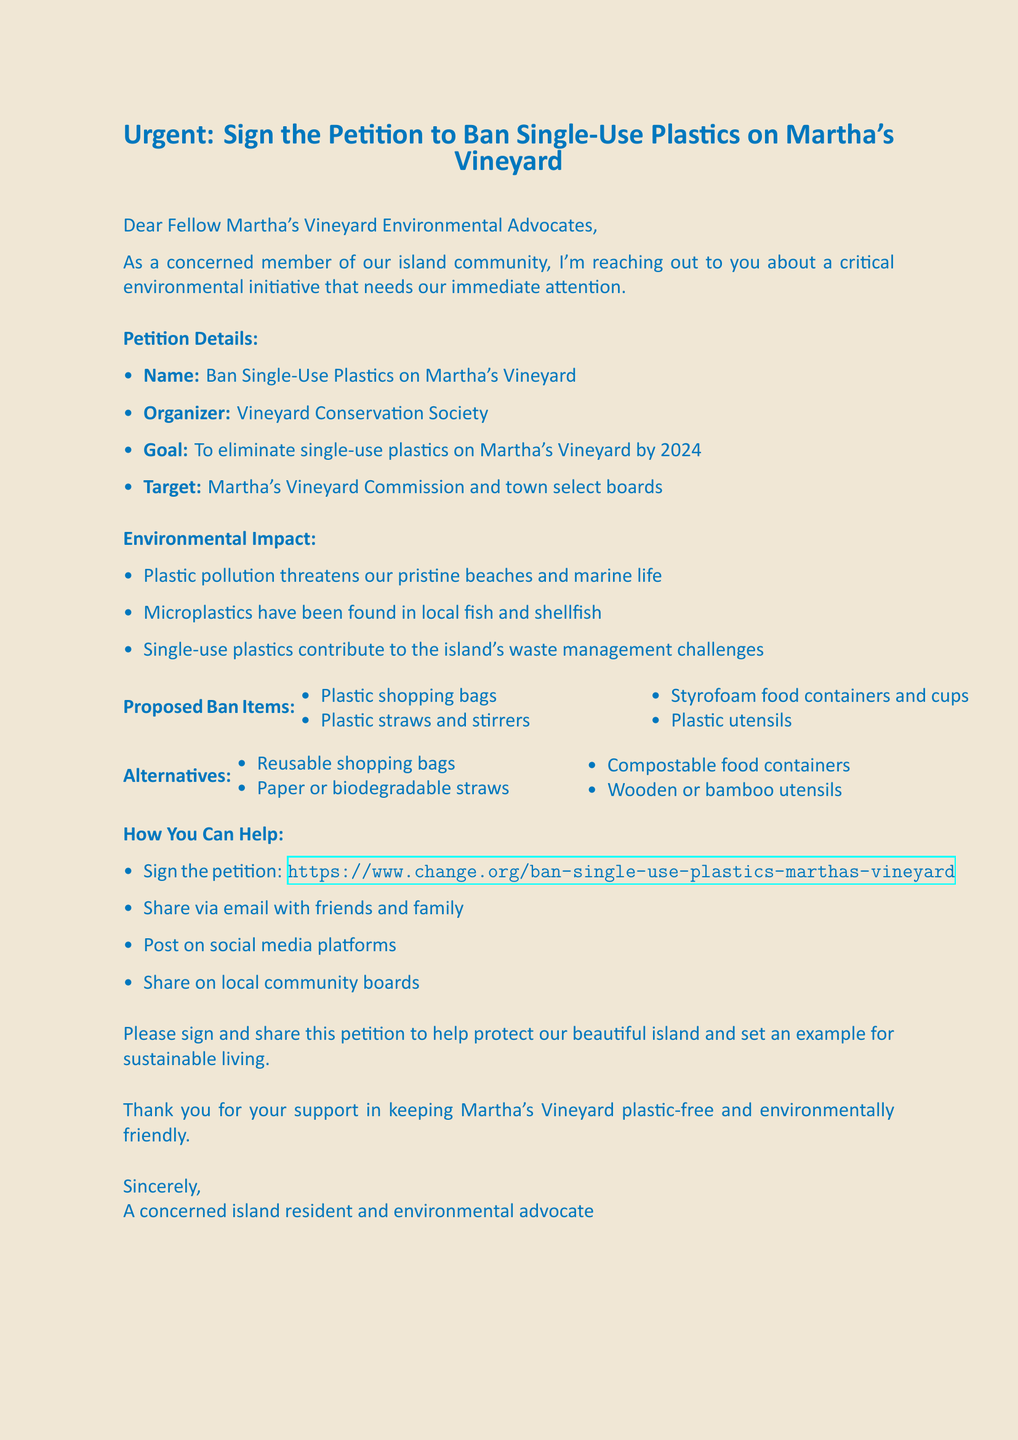What is the main goal of the petition? The main goal of the petition is to eliminate single-use plastics on Martha's Vineyard by 2024.
Answer: To eliminate single-use plastics on Martha's Vineyard by 2024 Who is organizing the petition? The petition is organized by the Vineyard Conservation Society.
Answer: Vineyard Conservation Society What items are proposed to be banned? The proposed ban items include various plastic products listed in the document.
Answer: Plastic shopping bags, plastic straws and stirrers, Styrofoam food containers and cups, plastic utensils What is one alternative to single-use plastics mentioned? The document mentions alternatives to single-use plastics, one of which is reusable shopping bags.
Answer: Reusable shopping bags What environmental issue is specifically mentioned regarding marine life? The document states that microplastics have been found in local fish and shellfish.
Answer: Microplastics have been found in local fish and shellfish How can supporters share the petition? Supporters can share the petition through various methods listed in the document.
Answer: Email, social media platforms, local community boards What is the call to action in the email? The call to action encourages recipients to sign and share the petition.
Answer: Please sign and share this petition to help protect our beautiful island and set an example for sustainable living What type of document is this? The document is an email notification regarding an online petition.
Answer: Email notification 